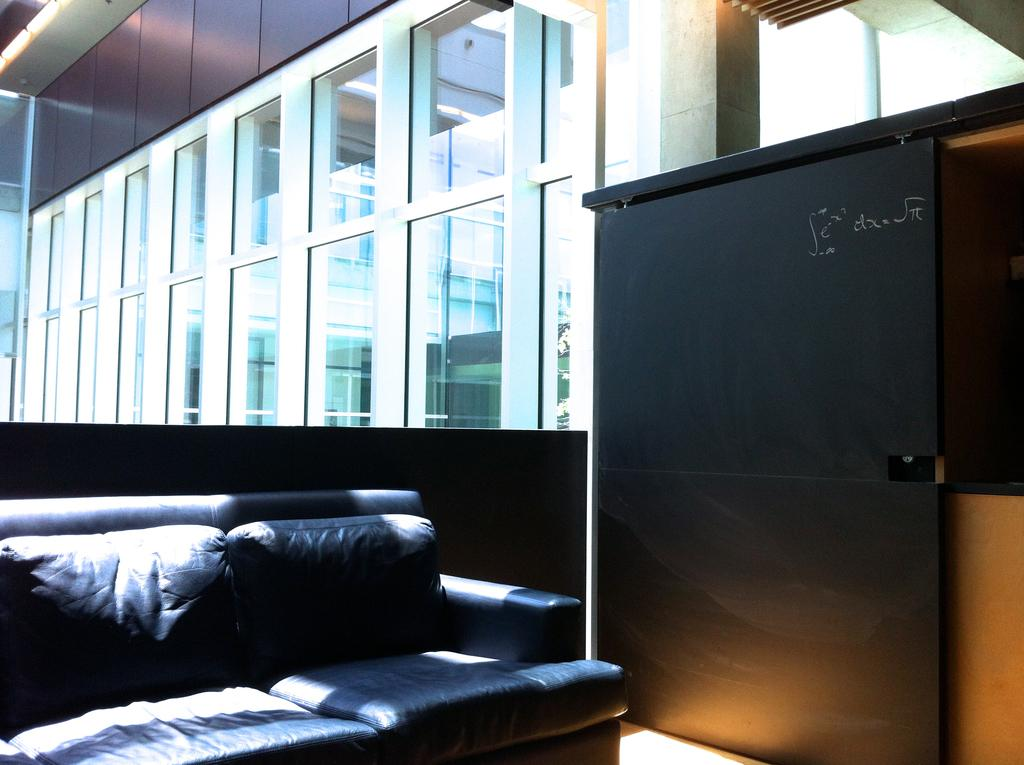Where was the image taken? The image was taken in a room. What is the main piece of furniture in the foreground of the image? There is a couch in the foreground of the image. What can be seen in the background of the image? There are glass windows in the background of the image. What is visible outside the windows? There is a building visible outside the window. Where is the giraffe located in the image? There is no giraffe present in the image. What type of basin is visible in the image? There is no basin present in the image. 